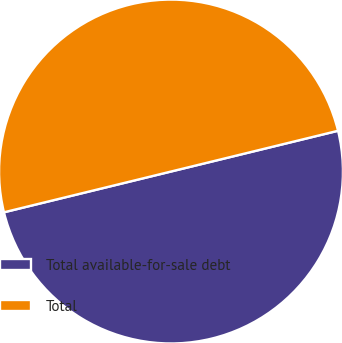Convert chart to OTSL. <chart><loc_0><loc_0><loc_500><loc_500><pie_chart><fcel>Total available-for-sale debt<fcel>Total<nl><fcel>50.0%<fcel>50.0%<nl></chart> 